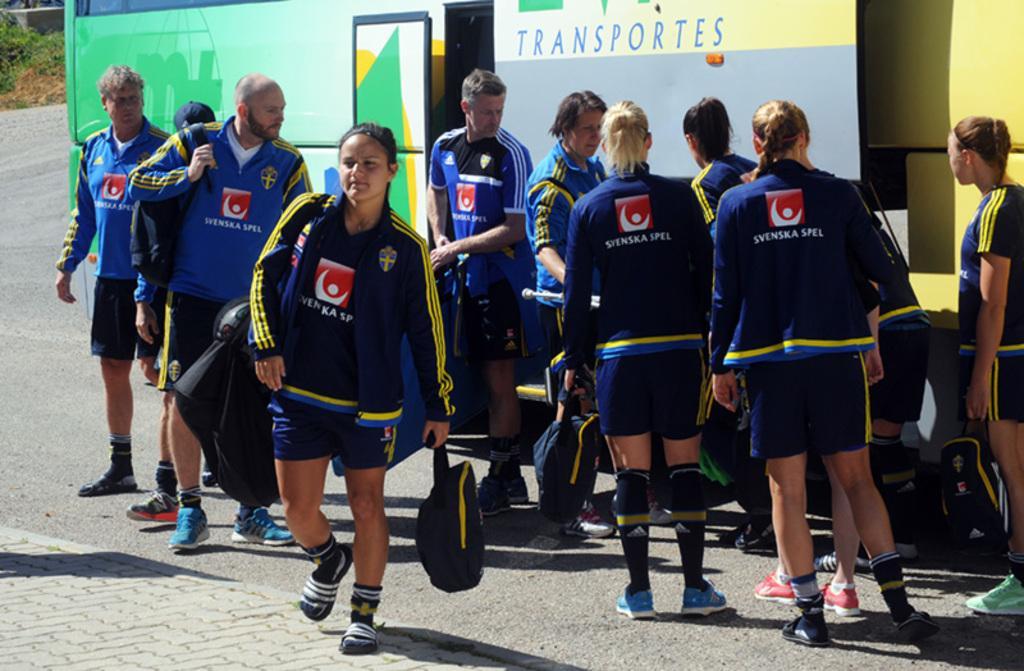Can you describe this image briefly? In this picture I can see there are a group of people standing and they are wearing a blue jersey´s and wearing coats and they are carrying bags and in the backdrop there is a bus and it has green, white and yellow color on the bus. In the backdrop there are plants into left and there is a road and there is a walk way. 